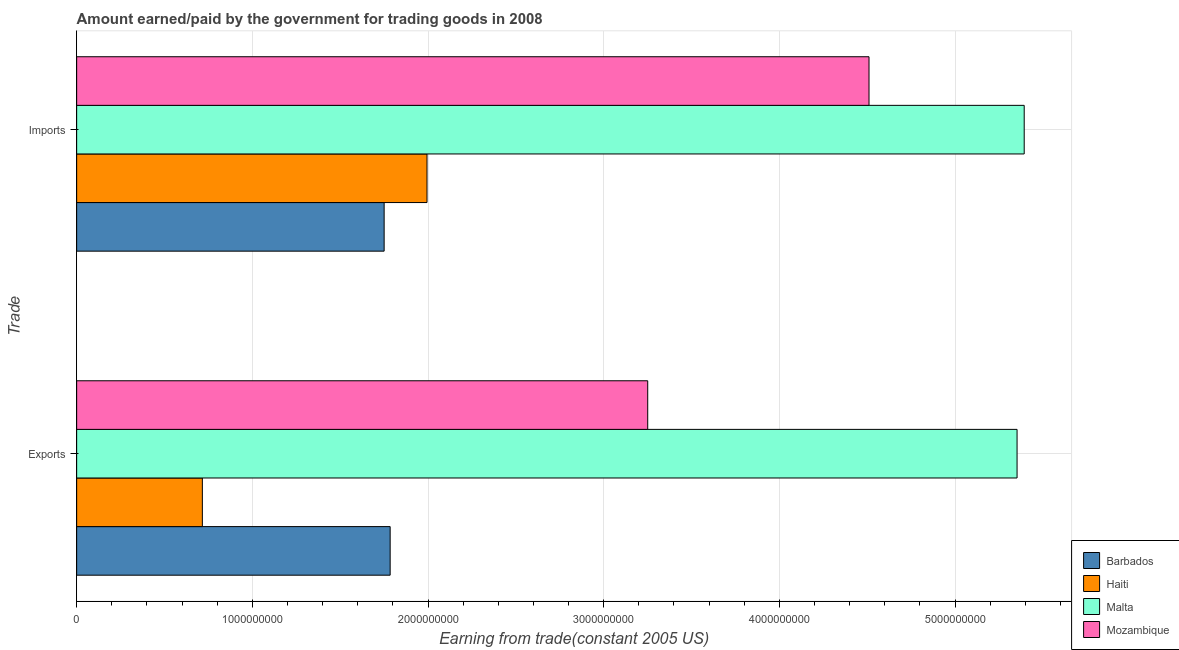Are the number of bars on each tick of the Y-axis equal?
Provide a succinct answer. Yes. How many bars are there on the 1st tick from the bottom?
Provide a short and direct response. 4. What is the label of the 1st group of bars from the top?
Offer a terse response. Imports. What is the amount earned from exports in Malta?
Keep it short and to the point. 5.35e+09. Across all countries, what is the maximum amount earned from exports?
Your answer should be compact. 5.35e+09. Across all countries, what is the minimum amount earned from exports?
Keep it short and to the point. 7.15e+08. In which country was the amount earned from exports maximum?
Provide a short and direct response. Malta. In which country was the amount paid for imports minimum?
Ensure brevity in your answer.  Barbados. What is the total amount paid for imports in the graph?
Provide a short and direct response. 1.36e+1. What is the difference between the amount earned from exports in Haiti and that in Mozambique?
Ensure brevity in your answer.  -2.54e+09. What is the difference between the amount paid for imports in Mozambique and the amount earned from exports in Barbados?
Offer a terse response. 2.73e+09. What is the average amount paid for imports per country?
Provide a short and direct response. 3.41e+09. What is the difference between the amount earned from exports and amount paid for imports in Malta?
Your answer should be very brief. -4.07e+07. What is the ratio of the amount earned from exports in Barbados to that in Malta?
Offer a very short reply. 0.33. In how many countries, is the amount paid for imports greater than the average amount paid for imports taken over all countries?
Your response must be concise. 2. What does the 3rd bar from the top in Exports represents?
Make the answer very short. Haiti. What does the 2nd bar from the bottom in Exports represents?
Your answer should be very brief. Haiti. How many bars are there?
Your response must be concise. 8. What is the difference between two consecutive major ticks on the X-axis?
Your response must be concise. 1.00e+09. Are the values on the major ticks of X-axis written in scientific E-notation?
Offer a very short reply. No. Does the graph contain grids?
Provide a short and direct response. Yes. Where does the legend appear in the graph?
Give a very brief answer. Bottom right. How many legend labels are there?
Offer a terse response. 4. What is the title of the graph?
Give a very brief answer. Amount earned/paid by the government for trading goods in 2008. Does "Sierra Leone" appear as one of the legend labels in the graph?
Offer a terse response. No. What is the label or title of the X-axis?
Provide a succinct answer. Earning from trade(constant 2005 US). What is the label or title of the Y-axis?
Make the answer very short. Trade. What is the Earning from trade(constant 2005 US) of Barbados in Exports?
Your answer should be compact. 1.78e+09. What is the Earning from trade(constant 2005 US) of Haiti in Exports?
Give a very brief answer. 7.15e+08. What is the Earning from trade(constant 2005 US) in Malta in Exports?
Provide a succinct answer. 5.35e+09. What is the Earning from trade(constant 2005 US) in Mozambique in Exports?
Your answer should be compact. 3.25e+09. What is the Earning from trade(constant 2005 US) in Barbados in Imports?
Make the answer very short. 1.75e+09. What is the Earning from trade(constant 2005 US) of Haiti in Imports?
Your answer should be compact. 1.99e+09. What is the Earning from trade(constant 2005 US) of Malta in Imports?
Provide a short and direct response. 5.39e+09. What is the Earning from trade(constant 2005 US) of Mozambique in Imports?
Give a very brief answer. 4.51e+09. Across all Trade, what is the maximum Earning from trade(constant 2005 US) in Barbados?
Your response must be concise. 1.78e+09. Across all Trade, what is the maximum Earning from trade(constant 2005 US) of Haiti?
Your answer should be very brief. 1.99e+09. Across all Trade, what is the maximum Earning from trade(constant 2005 US) of Malta?
Make the answer very short. 5.39e+09. Across all Trade, what is the maximum Earning from trade(constant 2005 US) of Mozambique?
Offer a very short reply. 4.51e+09. Across all Trade, what is the minimum Earning from trade(constant 2005 US) in Barbados?
Make the answer very short. 1.75e+09. Across all Trade, what is the minimum Earning from trade(constant 2005 US) of Haiti?
Your answer should be very brief. 7.15e+08. Across all Trade, what is the minimum Earning from trade(constant 2005 US) in Malta?
Provide a succinct answer. 5.35e+09. Across all Trade, what is the minimum Earning from trade(constant 2005 US) of Mozambique?
Give a very brief answer. 3.25e+09. What is the total Earning from trade(constant 2005 US) of Barbados in the graph?
Your answer should be very brief. 3.53e+09. What is the total Earning from trade(constant 2005 US) in Haiti in the graph?
Offer a terse response. 2.71e+09. What is the total Earning from trade(constant 2005 US) of Malta in the graph?
Offer a terse response. 1.07e+1. What is the total Earning from trade(constant 2005 US) in Mozambique in the graph?
Your answer should be compact. 7.76e+09. What is the difference between the Earning from trade(constant 2005 US) in Barbados in Exports and that in Imports?
Offer a very short reply. 3.43e+07. What is the difference between the Earning from trade(constant 2005 US) of Haiti in Exports and that in Imports?
Make the answer very short. -1.28e+09. What is the difference between the Earning from trade(constant 2005 US) of Malta in Exports and that in Imports?
Offer a very short reply. -4.07e+07. What is the difference between the Earning from trade(constant 2005 US) of Mozambique in Exports and that in Imports?
Offer a very short reply. -1.26e+09. What is the difference between the Earning from trade(constant 2005 US) of Barbados in Exports and the Earning from trade(constant 2005 US) of Haiti in Imports?
Ensure brevity in your answer.  -2.10e+08. What is the difference between the Earning from trade(constant 2005 US) in Barbados in Exports and the Earning from trade(constant 2005 US) in Malta in Imports?
Provide a succinct answer. -3.61e+09. What is the difference between the Earning from trade(constant 2005 US) in Barbados in Exports and the Earning from trade(constant 2005 US) in Mozambique in Imports?
Keep it short and to the point. -2.73e+09. What is the difference between the Earning from trade(constant 2005 US) in Haiti in Exports and the Earning from trade(constant 2005 US) in Malta in Imports?
Keep it short and to the point. -4.68e+09. What is the difference between the Earning from trade(constant 2005 US) in Haiti in Exports and the Earning from trade(constant 2005 US) in Mozambique in Imports?
Keep it short and to the point. -3.79e+09. What is the difference between the Earning from trade(constant 2005 US) in Malta in Exports and the Earning from trade(constant 2005 US) in Mozambique in Imports?
Provide a succinct answer. 8.43e+08. What is the average Earning from trade(constant 2005 US) of Barbados per Trade?
Offer a very short reply. 1.77e+09. What is the average Earning from trade(constant 2005 US) of Haiti per Trade?
Offer a very short reply. 1.35e+09. What is the average Earning from trade(constant 2005 US) of Malta per Trade?
Give a very brief answer. 5.37e+09. What is the average Earning from trade(constant 2005 US) of Mozambique per Trade?
Offer a very short reply. 3.88e+09. What is the difference between the Earning from trade(constant 2005 US) of Barbados and Earning from trade(constant 2005 US) of Haiti in Exports?
Offer a terse response. 1.07e+09. What is the difference between the Earning from trade(constant 2005 US) of Barbados and Earning from trade(constant 2005 US) of Malta in Exports?
Give a very brief answer. -3.57e+09. What is the difference between the Earning from trade(constant 2005 US) of Barbados and Earning from trade(constant 2005 US) of Mozambique in Exports?
Offer a very short reply. -1.47e+09. What is the difference between the Earning from trade(constant 2005 US) of Haiti and Earning from trade(constant 2005 US) of Malta in Exports?
Your answer should be compact. -4.64e+09. What is the difference between the Earning from trade(constant 2005 US) of Haiti and Earning from trade(constant 2005 US) of Mozambique in Exports?
Offer a very short reply. -2.54e+09. What is the difference between the Earning from trade(constant 2005 US) in Malta and Earning from trade(constant 2005 US) in Mozambique in Exports?
Your response must be concise. 2.10e+09. What is the difference between the Earning from trade(constant 2005 US) of Barbados and Earning from trade(constant 2005 US) of Haiti in Imports?
Your answer should be very brief. -2.44e+08. What is the difference between the Earning from trade(constant 2005 US) in Barbados and Earning from trade(constant 2005 US) in Malta in Imports?
Your answer should be very brief. -3.64e+09. What is the difference between the Earning from trade(constant 2005 US) in Barbados and Earning from trade(constant 2005 US) in Mozambique in Imports?
Keep it short and to the point. -2.76e+09. What is the difference between the Earning from trade(constant 2005 US) of Haiti and Earning from trade(constant 2005 US) of Malta in Imports?
Your answer should be very brief. -3.40e+09. What is the difference between the Earning from trade(constant 2005 US) of Haiti and Earning from trade(constant 2005 US) of Mozambique in Imports?
Provide a short and direct response. -2.52e+09. What is the difference between the Earning from trade(constant 2005 US) of Malta and Earning from trade(constant 2005 US) of Mozambique in Imports?
Your response must be concise. 8.83e+08. What is the ratio of the Earning from trade(constant 2005 US) of Barbados in Exports to that in Imports?
Provide a short and direct response. 1.02. What is the ratio of the Earning from trade(constant 2005 US) of Haiti in Exports to that in Imports?
Offer a very short reply. 0.36. What is the ratio of the Earning from trade(constant 2005 US) of Malta in Exports to that in Imports?
Your answer should be compact. 0.99. What is the ratio of the Earning from trade(constant 2005 US) in Mozambique in Exports to that in Imports?
Offer a terse response. 0.72. What is the difference between the highest and the second highest Earning from trade(constant 2005 US) in Barbados?
Offer a very short reply. 3.43e+07. What is the difference between the highest and the second highest Earning from trade(constant 2005 US) in Haiti?
Make the answer very short. 1.28e+09. What is the difference between the highest and the second highest Earning from trade(constant 2005 US) in Malta?
Provide a succinct answer. 4.07e+07. What is the difference between the highest and the second highest Earning from trade(constant 2005 US) in Mozambique?
Provide a short and direct response. 1.26e+09. What is the difference between the highest and the lowest Earning from trade(constant 2005 US) of Barbados?
Your answer should be compact. 3.43e+07. What is the difference between the highest and the lowest Earning from trade(constant 2005 US) in Haiti?
Make the answer very short. 1.28e+09. What is the difference between the highest and the lowest Earning from trade(constant 2005 US) of Malta?
Give a very brief answer. 4.07e+07. What is the difference between the highest and the lowest Earning from trade(constant 2005 US) in Mozambique?
Your response must be concise. 1.26e+09. 